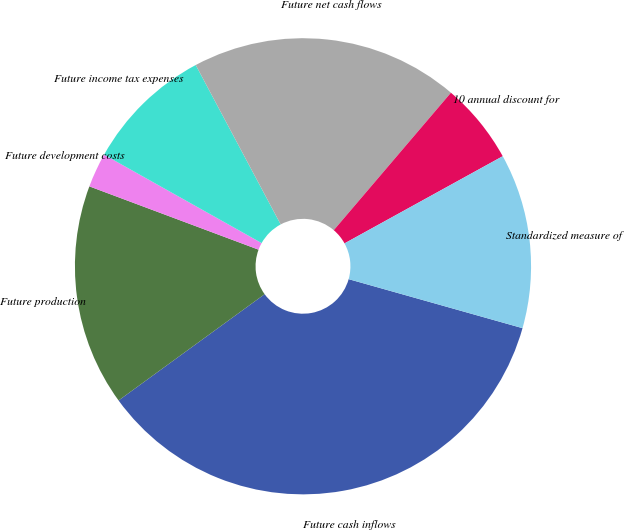Convert chart to OTSL. <chart><loc_0><loc_0><loc_500><loc_500><pie_chart><fcel>Future cash inflows<fcel>Future production<fcel>Future development costs<fcel>Future income tax expenses<fcel>Future net cash flows<fcel>10 annual discount for<fcel>Standardized measure of<nl><fcel>35.62%<fcel>15.71%<fcel>2.44%<fcel>9.07%<fcel>19.03%<fcel>5.75%<fcel>12.39%<nl></chart> 